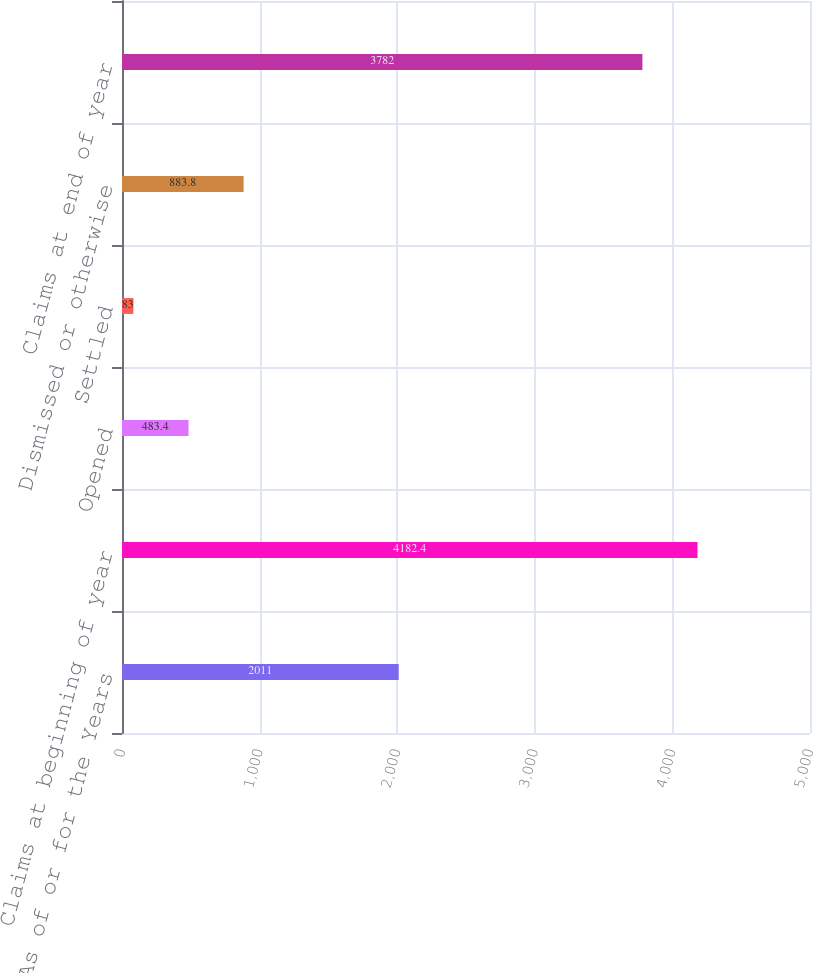<chart> <loc_0><loc_0><loc_500><loc_500><bar_chart><fcel>As of or for the Years<fcel>Claims at beginning of year<fcel>Opened<fcel>Settled<fcel>Dismissed or otherwise<fcel>Claims at end of year<nl><fcel>2011<fcel>4182.4<fcel>483.4<fcel>83<fcel>883.8<fcel>3782<nl></chart> 